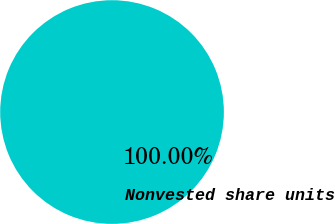Convert chart to OTSL. <chart><loc_0><loc_0><loc_500><loc_500><pie_chart><fcel>Nonvested share units<nl><fcel>100.0%<nl></chart> 